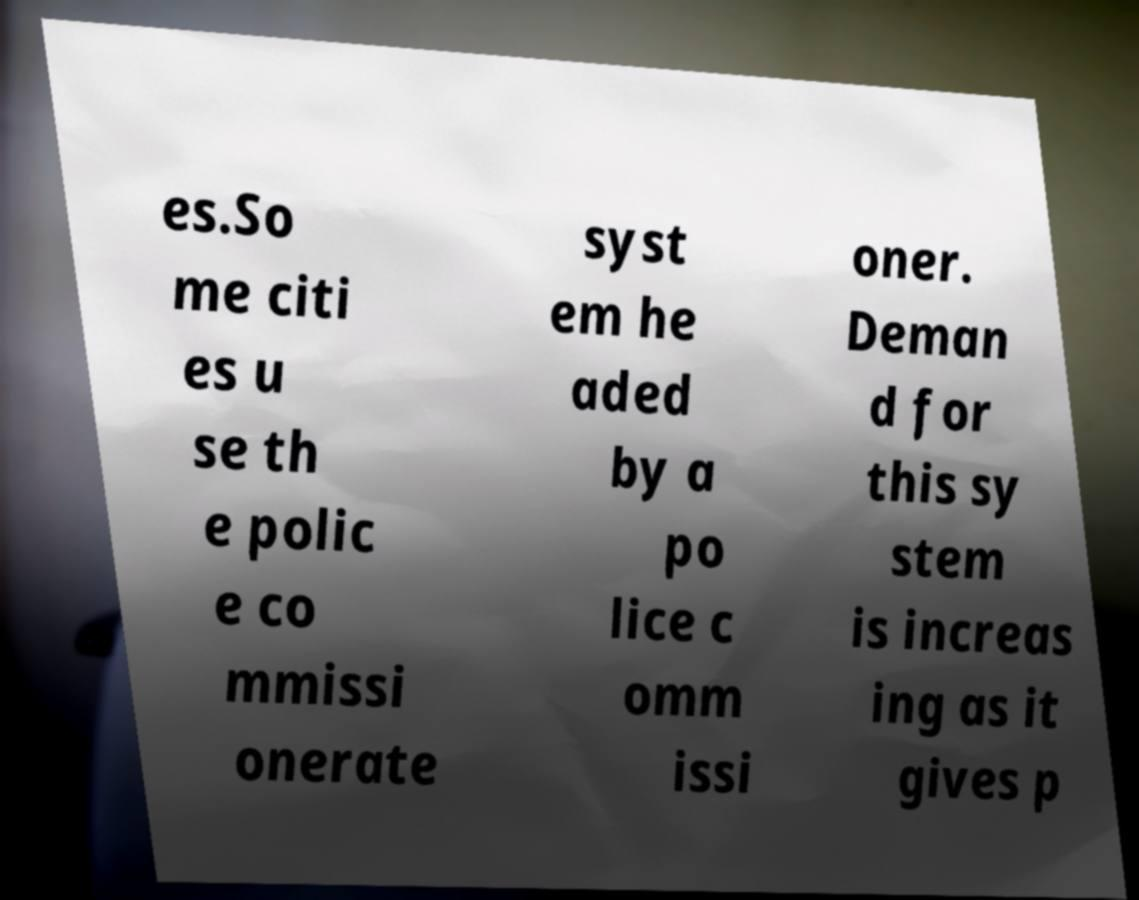Could you assist in decoding the text presented in this image and type it out clearly? es.So me citi es u se th e polic e co mmissi onerate syst em he aded by a po lice c omm issi oner. Deman d for this sy stem is increas ing as it gives p 